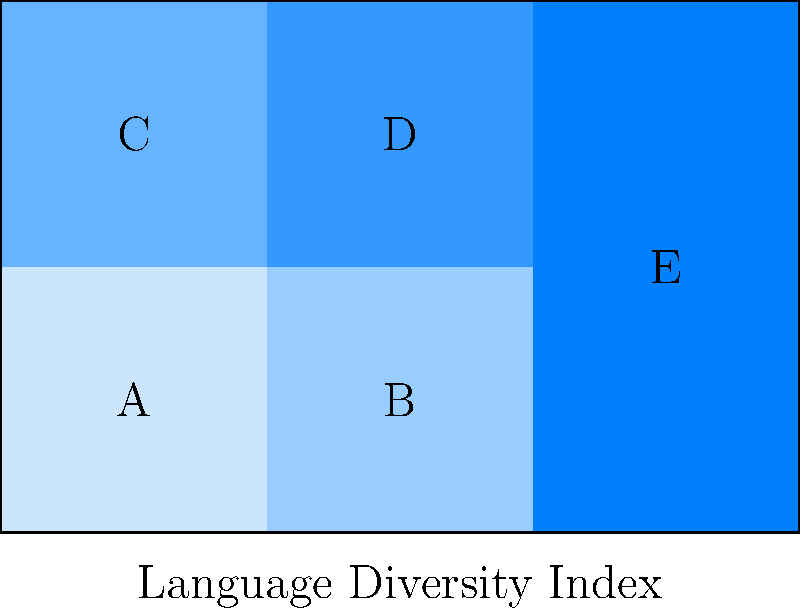The choropleth map above represents the Language Diversity Index (LDI) for five regions in a country, with darker shades indicating higher linguistic diversity. Which region is most likely to exhibit strong separatist tendencies, and why? To determine which region is most likely to exhibit strong separatist tendencies based on linguistic diversity, we need to analyze the map and consider the relationship between language diversity and separatist movements:

1. Interpret the map:
   - The map shows five regions (A, B, C, D, and E) with varying shades of blue.
   - Darker shades indicate higher linguistic diversity.
   - Region E has the darkest shade, followed by D, C, B, and A (lightest).

2. Understand the relationship between linguistic diversity and separatism:
   - Higher linguistic diversity often correlates with stronger cultural distinctions.
   - Regions with distinct languages may have a stronger sense of separate identity.
   - This distinct identity can fuel desires for autonomy or independence.

3. Analyze each region:
   - Region E has the highest LDI, suggesting the greatest linguistic diversity.
   - Regions D and C have moderate to high LDI.
   - Regions B and A have lower LDI, indicating less linguistic diversity.

4. Consider the impact of linguistic diversity on separatist tendencies:
   - Region E, with the highest linguistic diversity, is most likely to have multiple distinct language communities.
   - This diversity can lead to:
     a) Stronger cultural distinctions from the rest of the country
     b) Potential challenges in national integration
     c) A more pronounced sense of separate identity

5. Conclusion:
   Region E, having the highest Language Diversity Index, is most likely to exhibit strong separatist tendencies. The presence of multiple language communities can foster a sense of distinctiveness from the national identity, potentially leading to demands for greater autonomy or even independence.
Answer: Region E 